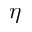<formula> <loc_0><loc_0><loc_500><loc_500>\eta</formula> 